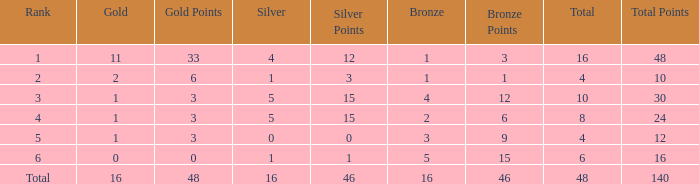What is the total gold that has bronze less than 2, a silver of 1 and total more than 4? None. 